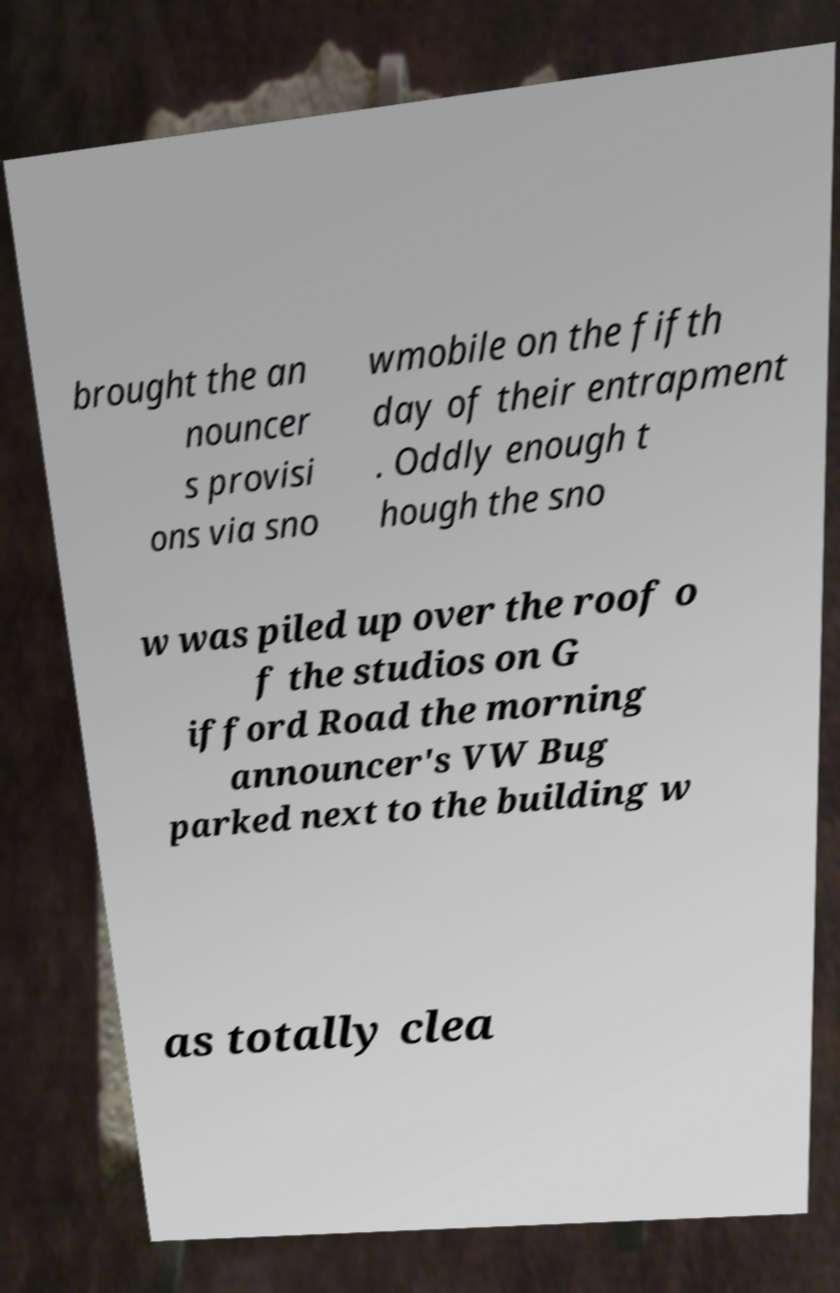Could you extract and type out the text from this image? brought the an nouncer s provisi ons via sno wmobile on the fifth day of their entrapment . Oddly enough t hough the sno w was piled up over the roof o f the studios on G ifford Road the morning announcer's VW Bug parked next to the building w as totally clea 